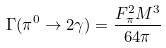<formula> <loc_0><loc_0><loc_500><loc_500>\Gamma ( \pi ^ { 0 } \rightarrow 2 \gamma ) = \frac { F _ { \pi } ^ { 2 } M ^ { 3 } } { 6 4 \pi }</formula> 